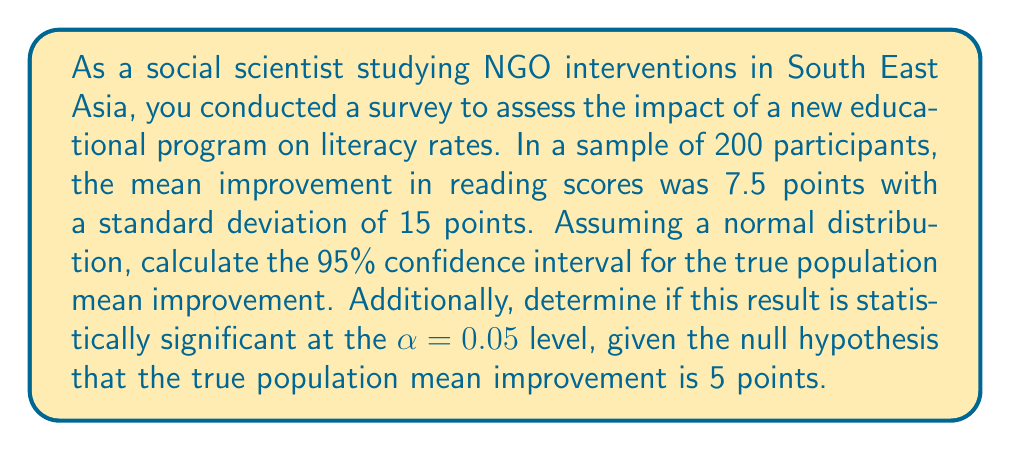Can you solve this math problem? To solve this problem, we'll follow these steps:

1. Calculate the standard error of the mean (SEM)
2. Compute the 95% confidence interval
3. Perform a hypothesis test to determine statistical significance

Step 1: Calculate the standard error of the mean (SEM)
The formula for SEM is:
$$ SEM = \frac{s}{\sqrt{n}} $$
Where s is the sample standard deviation and n is the sample size.

$$ SEM = \frac{15}{\sqrt{200}} = \frac{15}{14.14} = 1.06 $$

Step 2: Compute the 95% confidence interval
For a 95% confidence interval, we use a z-score of 1.96. The formula is:
$$ CI = \bar{x} \pm (z \times SEM) $$
Where $\bar{x}$ is the sample mean.

$$ CI = 7.5 \pm (1.96 \times 1.06) $$
$$ CI = 7.5 \pm 2.08 $$
$$ CI = (5.42, 9.58) $$

Step 3: Perform a hypothesis test
We'll use a one-sample z-test since the sample size is large (n > 30).

Null hypothesis: $H_0: \mu = 5$
Alternative hypothesis: $H_a: \mu \neq 5$

Calculate the z-score:
$$ z = \frac{\bar{x} - \mu_0}{SEM} = \frac{7.5 - 5}{1.06} = 2.36 $$

Calculate the p-value:
For a two-tailed test, p-value = $2 \times P(Z > |z|)$
Using a standard normal distribution table or calculator, we find:
$$ p-value = 2 \times P(Z > 2.36) = 2 \times 0.0091 = 0.0182 $$

Since the p-value (0.0182) is less than the significance level (α = 0.05), we reject the null hypothesis.
Answer: The 95% confidence interval for the true population mean improvement is (5.42, 9.58) points. The result is statistically significant at the α = 0.05 level (p-value = 0.0182), indicating strong evidence against the null hypothesis that the true population mean improvement is 5 points. 